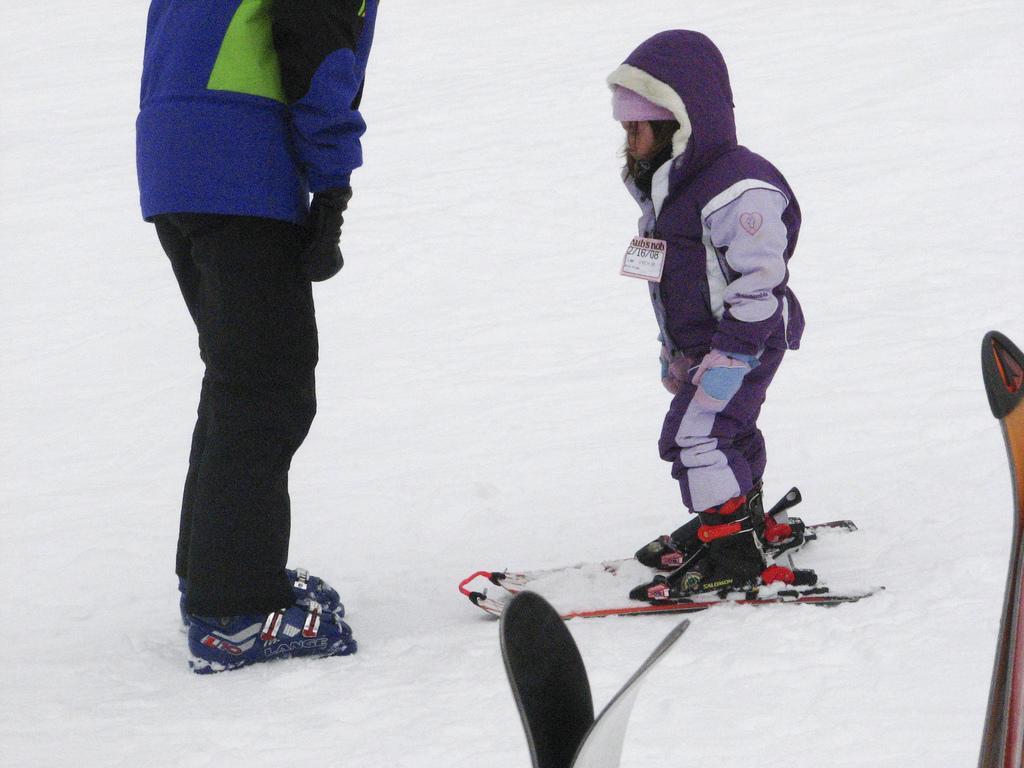Can you describe this image briefly? In this picture there is a person standing on the ski boards. There is an another person standing. In the foreground there are ski boards. At the bottom there is snow. 